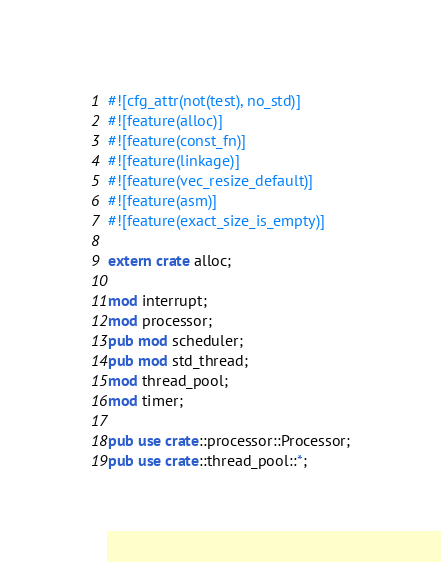Convert code to text. <code><loc_0><loc_0><loc_500><loc_500><_Rust_>#![cfg_attr(not(test), no_std)]
#![feature(alloc)]
#![feature(const_fn)]
#![feature(linkage)]
#![feature(vec_resize_default)]
#![feature(asm)]
#![feature(exact_size_is_empty)]

extern crate alloc;

mod interrupt;
mod processor;
pub mod scheduler;
pub mod std_thread;
mod thread_pool;
mod timer;

pub use crate::processor::Processor;
pub use crate::thread_pool::*;
</code> 